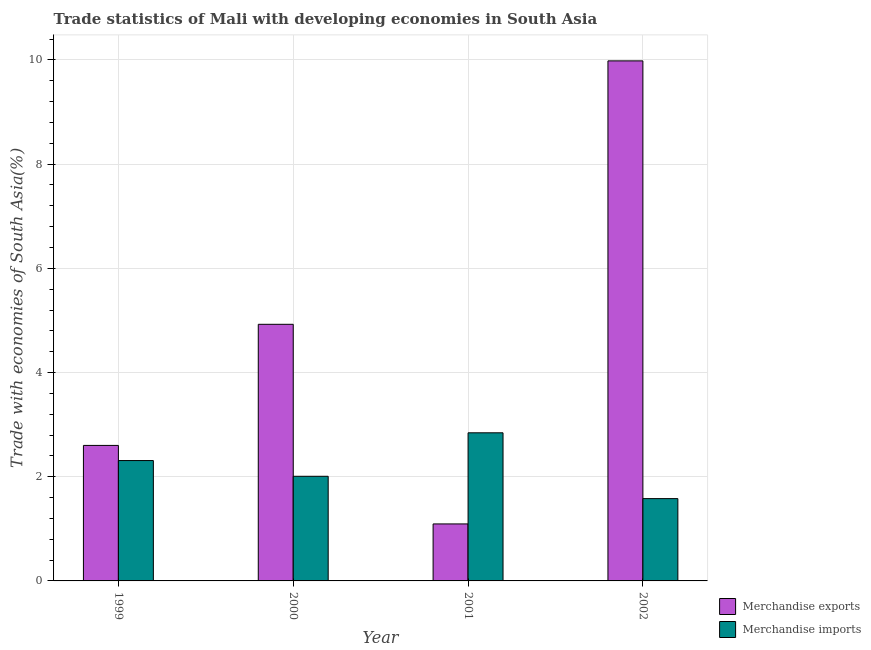How many different coloured bars are there?
Your answer should be compact. 2. Are the number of bars per tick equal to the number of legend labels?
Your response must be concise. Yes. How many bars are there on the 1st tick from the left?
Ensure brevity in your answer.  2. In how many cases, is the number of bars for a given year not equal to the number of legend labels?
Your answer should be compact. 0. What is the merchandise exports in 2002?
Offer a very short reply. 9.98. Across all years, what is the maximum merchandise exports?
Your answer should be compact. 9.98. Across all years, what is the minimum merchandise exports?
Provide a short and direct response. 1.09. In which year was the merchandise imports minimum?
Give a very brief answer. 2002. What is the total merchandise exports in the graph?
Offer a very short reply. 18.6. What is the difference between the merchandise exports in 1999 and that in 2000?
Your answer should be very brief. -2.32. What is the difference between the merchandise exports in 2001 and the merchandise imports in 2002?
Provide a succinct answer. -8.89. What is the average merchandise exports per year?
Provide a short and direct response. 4.65. In the year 2002, what is the difference between the merchandise imports and merchandise exports?
Your answer should be very brief. 0. What is the ratio of the merchandise exports in 2000 to that in 2002?
Ensure brevity in your answer.  0.49. What is the difference between the highest and the second highest merchandise exports?
Your answer should be very brief. 5.06. What is the difference between the highest and the lowest merchandise imports?
Keep it short and to the point. 1.26. In how many years, is the merchandise imports greater than the average merchandise imports taken over all years?
Make the answer very short. 2. What does the 1st bar from the left in 2002 represents?
Give a very brief answer. Merchandise exports. How many years are there in the graph?
Offer a very short reply. 4. What is the difference between two consecutive major ticks on the Y-axis?
Your answer should be compact. 2. Are the values on the major ticks of Y-axis written in scientific E-notation?
Your response must be concise. No. How many legend labels are there?
Your answer should be compact. 2. How are the legend labels stacked?
Give a very brief answer. Vertical. What is the title of the graph?
Your response must be concise. Trade statistics of Mali with developing economies in South Asia. Does "Females" appear as one of the legend labels in the graph?
Your answer should be very brief. No. What is the label or title of the X-axis?
Keep it short and to the point. Year. What is the label or title of the Y-axis?
Provide a succinct answer. Trade with economies of South Asia(%). What is the Trade with economies of South Asia(%) of Merchandise exports in 1999?
Provide a short and direct response. 2.6. What is the Trade with economies of South Asia(%) of Merchandise imports in 1999?
Ensure brevity in your answer.  2.31. What is the Trade with economies of South Asia(%) of Merchandise exports in 2000?
Your answer should be very brief. 4.93. What is the Trade with economies of South Asia(%) in Merchandise imports in 2000?
Your response must be concise. 2.01. What is the Trade with economies of South Asia(%) in Merchandise exports in 2001?
Offer a very short reply. 1.09. What is the Trade with economies of South Asia(%) of Merchandise imports in 2001?
Give a very brief answer. 2.84. What is the Trade with economies of South Asia(%) in Merchandise exports in 2002?
Provide a short and direct response. 9.98. What is the Trade with economies of South Asia(%) in Merchandise imports in 2002?
Offer a very short reply. 1.58. Across all years, what is the maximum Trade with economies of South Asia(%) in Merchandise exports?
Ensure brevity in your answer.  9.98. Across all years, what is the maximum Trade with economies of South Asia(%) in Merchandise imports?
Provide a short and direct response. 2.84. Across all years, what is the minimum Trade with economies of South Asia(%) of Merchandise exports?
Keep it short and to the point. 1.09. Across all years, what is the minimum Trade with economies of South Asia(%) of Merchandise imports?
Offer a very short reply. 1.58. What is the total Trade with economies of South Asia(%) of Merchandise exports in the graph?
Ensure brevity in your answer.  18.6. What is the total Trade with economies of South Asia(%) of Merchandise imports in the graph?
Your answer should be very brief. 8.74. What is the difference between the Trade with economies of South Asia(%) of Merchandise exports in 1999 and that in 2000?
Offer a terse response. -2.32. What is the difference between the Trade with economies of South Asia(%) of Merchandise imports in 1999 and that in 2000?
Give a very brief answer. 0.3. What is the difference between the Trade with economies of South Asia(%) of Merchandise exports in 1999 and that in 2001?
Your answer should be compact. 1.51. What is the difference between the Trade with economies of South Asia(%) of Merchandise imports in 1999 and that in 2001?
Ensure brevity in your answer.  -0.53. What is the difference between the Trade with economies of South Asia(%) of Merchandise exports in 1999 and that in 2002?
Offer a very short reply. -7.38. What is the difference between the Trade with economies of South Asia(%) of Merchandise imports in 1999 and that in 2002?
Ensure brevity in your answer.  0.73. What is the difference between the Trade with economies of South Asia(%) of Merchandise exports in 2000 and that in 2001?
Provide a succinct answer. 3.83. What is the difference between the Trade with economies of South Asia(%) in Merchandise imports in 2000 and that in 2001?
Give a very brief answer. -0.83. What is the difference between the Trade with economies of South Asia(%) in Merchandise exports in 2000 and that in 2002?
Your answer should be very brief. -5.06. What is the difference between the Trade with economies of South Asia(%) in Merchandise imports in 2000 and that in 2002?
Keep it short and to the point. 0.43. What is the difference between the Trade with economies of South Asia(%) in Merchandise exports in 2001 and that in 2002?
Keep it short and to the point. -8.89. What is the difference between the Trade with economies of South Asia(%) of Merchandise imports in 2001 and that in 2002?
Provide a succinct answer. 1.26. What is the difference between the Trade with economies of South Asia(%) of Merchandise exports in 1999 and the Trade with economies of South Asia(%) of Merchandise imports in 2000?
Offer a very short reply. 0.59. What is the difference between the Trade with economies of South Asia(%) of Merchandise exports in 1999 and the Trade with economies of South Asia(%) of Merchandise imports in 2001?
Offer a very short reply. -0.24. What is the difference between the Trade with economies of South Asia(%) in Merchandise exports in 1999 and the Trade with economies of South Asia(%) in Merchandise imports in 2002?
Provide a short and direct response. 1.02. What is the difference between the Trade with economies of South Asia(%) of Merchandise exports in 2000 and the Trade with economies of South Asia(%) of Merchandise imports in 2001?
Your answer should be very brief. 2.08. What is the difference between the Trade with economies of South Asia(%) of Merchandise exports in 2000 and the Trade with economies of South Asia(%) of Merchandise imports in 2002?
Offer a very short reply. 3.35. What is the difference between the Trade with economies of South Asia(%) of Merchandise exports in 2001 and the Trade with economies of South Asia(%) of Merchandise imports in 2002?
Offer a very short reply. -0.49. What is the average Trade with economies of South Asia(%) in Merchandise exports per year?
Ensure brevity in your answer.  4.65. What is the average Trade with economies of South Asia(%) in Merchandise imports per year?
Offer a terse response. 2.19. In the year 1999, what is the difference between the Trade with economies of South Asia(%) in Merchandise exports and Trade with economies of South Asia(%) in Merchandise imports?
Offer a very short reply. 0.29. In the year 2000, what is the difference between the Trade with economies of South Asia(%) of Merchandise exports and Trade with economies of South Asia(%) of Merchandise imports?
Provide a succinct answer. 2.92. In the year 2001, what is the difference between the Trade with economies of South Asia(%) of Merchandise exports and Trade with economies of South Asia(%) of Merchandise imports?
Your response must be concise. -1.75. In the year 2002, what is the difference between the Trade with economies of South Asia(%) in Merchandise exports and Trade with economies of South Asia(%) in Merchandise imports?
Offer a terse response. 8.4. What is the ratio of the Trade with economies of South Asia(%) of Merchandise exports in 1999 to that in 2000?
Give a very brief answer. 0.53. What is the ratio of the Trade with economies of South Asia(%) in Merchandise imports in 1999 to that in 2000?
Keep it short and to the point. 1.15. What is the ratio of the Trade with economies of South Asia(%) in Merchandise exports in 1999 to that in 2001?
Your answer should be compact. 2.38. What is the ratio of the Trade with economies of South Asia(%) in Merchandise imports in 1999 to that in 2001?
Your response must be concise. 0.81. What is the ratio of the Trade with economies of South Asia(%) in Merchandise exports in 1999 to that in 2002?
Give a very brief answer. 0.26. What is the ratio of the Trade with economies of South Asia(%) in Merchandise imports in 1999 to that in 2002?
Your response must be concise. 1.46. What is the ratio of the Trade with economies of South Asia(%) of Merchandise exports in 2000 to that in 2001?
Provide a succinct answer. 4.5. What is the ratio of the Trade with economies of South Asia(%) of Merchandise imports in 2000 to that in 2001?
Make the answer very short. 0.71. What is the ratio of the Trade with economies of South Asia(%) of Merchandise exports in 2000 to that in 2002?
Your response must be concise. 0.49. What is the ratio of the Trade with economies of South Asia(%) in Merchandise imports in 2000 to that in 2002?
Keep it short and to the point. 1.27. What is the ratio of the Trade with economies of South Asia(%) in Merchandise exports in 2001 to that in 2002?
Your answer should be very brief. 0.11. What is the ratio of the Trade with economies of South Asia(%) of Merchandise imports in 2001 to that in 2002?
Offer a very short reply. 1.8. What is the difference between the highest and the second highest Trade with economies of South Asia(%) of Merchandise exports?
Provide a succinct answer. 5.06. What is the difference between the highest and the second highest Trade with economies of South Asia(%) of Merchandise imports?
Offer a terse response. 0.53. What is the difference between the highest and the lowest Trade with economies of South Asia(%) of Merchandise exports?
Offer a terse response. 8.89. What is the difference between the highest and the lowest Trade with economies of South Asia(%) of Merchandise imports?
Give a very brief answer. 1.26. 